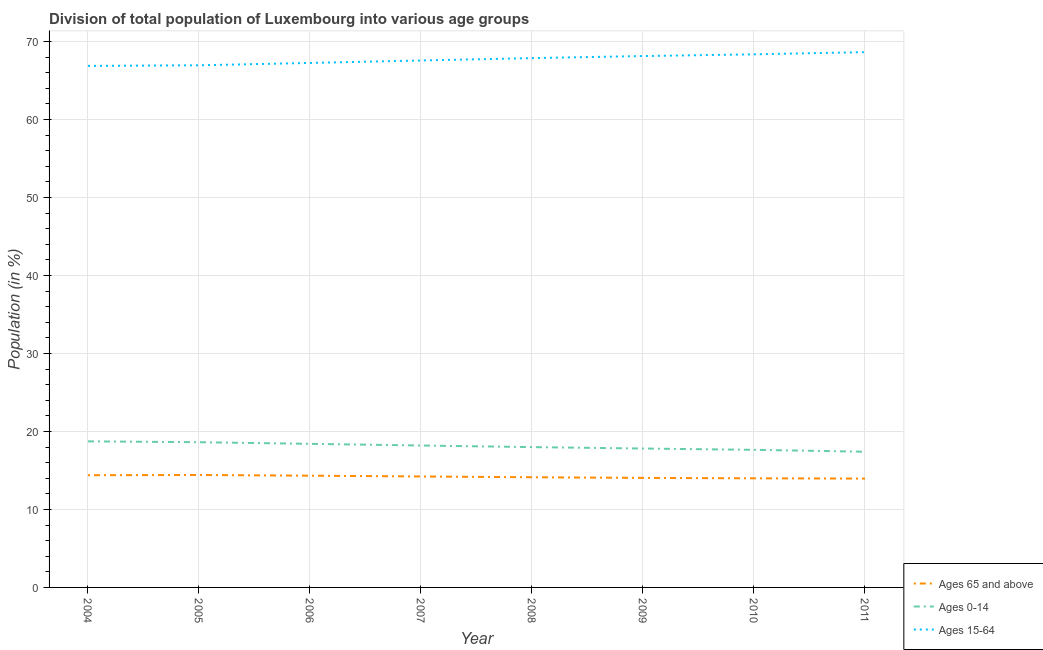Does the line corresponding to percentage of population within the age-group 15-64 intersect with the line corresponding to percentage of population within the age-group 0-14?
Your response must be concise. No. What is the percentage of population within the age-group of 65 and above in 2004?
Provide a short and direct response. 14.39. Across all years, what is the maximum percentage of population within the age-group 0-14?
Give a very brief answer. 18.73. Across all years, what is the minimum percentage of population within the age-group 0-14?
Ensure brevity in your answer.  17.4. In which year was the percentage of population within the age-group of 65 and above maximum?
Your answer should be compact. 2005. What is the total percentage of population within the age-group of 65 and above in the graph?
Keep it short and to the point. 113.49. What is the difference between the percentage of population within the age-group of 65 and above in 2007 and that in 2011?
Provide a short and direct response. 0.27. What is the difference between the percentage of population within the age-group of 65 and above in 2008 and the percentage of population within the age-group 0-14 in 2005?
Provide a succinct answer. -4.49. What is the average percentage of population within the age-group of 65 and above per year?
Provide a succinct answer. 14.19. In the year 2008, what is the difference between the percentage of population within the age-group of 65 and above and percentage of population within the age-group 0-14?
Make the answer very short. -3.87. What is the ratio of the percentage of population within the age-group of 65 and above in 2006 to that in 2009?
Keep it short and to the point. 1.02. Is the percentage of population within the age-group 0-14 in 2004 less than that in 2007?
Give a very brief answer. No. Is the difference between the percentage of population within the age-group of 65 and above in 2004 and 2009 greater than the difference between the percentage of population within the age-group 15-64 in 2004 and 2009?
Provide a succinct answer. Yes. What is the difference between the highest and the second highest percentage of population within the age-group 15-64?
Offer a very short reply. 0.28. What is the difference between the highest and the lowest percentage of population within the age-group of 65 and above?
Provide a short and direct response. 0.47. Is the sum of the percentage of population within the age-group of 65 and above in 2005 and 2009 greater than the maximum percentage of population within the age-group 15-64 across all years?
Ensure brevity in your answer.  No. Is it the case that in every year, the sum of the percentage of population within the age-group of 65 and above and percentage of population within the age-group 0-14 is greater than the percentage of population within the age-group 15-64?
Your answer should be very brief. No. Does the percentage of population within the age-group 0-14 monotonically increase over the years?
Provide a short and direct response. No. Is the percentage of population within the age-group 15-64 strictly greater than the percentage of population within the age-group of 65 and above over the years?
Keep it short and to the point. Yes. Is the percentage of population within the age-group 15-64 strictly less than the percentage of population within the age-group 0-14 over the years?
Make the answer very short. No. How many years are there in the graph?
Keep it short and to the point. 8. What is the difference between two consecutive major ticks on the Y-axis?
Provide a succinct answer. 10. Does the graph contain any zero values?
Your answer should be very brief. No. Does the graph contain grids?
Keep it short and to the point. Yes. What is the title of the graph?
Ensure brevity in your answer.  Division of total population of Luxembourg into various age groups
. What is the label or title of the X-axis?
Ensure brevity in your answer.  Year. What is the Population (in %) in Ages 65 and above in 2004?
Offer a very short reply. 14.39. What is the Population (in %) in Ages 0-14 in 2004?
Your answer should be compact. 18.73. What is the Population (in %) of Ages 15-64 in 2004?
Provide a short and direct response. 66.88. What is the Population (in %) in Ages 65 and above in 2005?
Your answer should be compact. 14.42. What is the Population (in %) of Ages 0-14 in 2005?
Give a very brief answer. 18.62. What is the Population (in %) in Ages 15-64 in 2005?
Provide a succinct answer. 66.96. What is the Population (in %) in Ages 65 and above in 2006?
Your response must be concise. 14.33. What is the Population (in %) in Ages 0-14 in 2006?
Provide a succinct answer. 18.41. What is the Population (in %) in Ages 15-64 in 2006?
Ensure brevity in your answer.  67.26. What is the Population (in %) in Ages 65 and above in 2007?
Your answer should be very brief. 14.23. What is the Population (in %) of Ages 0-14 in 2007?
Give a very brief answer. 18.2. What is the Population (in %) in Ages 15-64 in 2007?
Provide a succinct answer. 67.57. What is the Population (in %) of Ages 65 and above in 2008?
Make the answer very short. 14.13. What is the Population (in %) of Ages 0-14 in 2008?
Ensure brevity in your answer.  17.99. What is the Population (in %) of Ages 15-64 in 2008?
Offer a very short reply. 67.88. What is the Population (in %) of Ages 65 and above in 2009?
Make the answer very short. 14.05. What is the Population (in %) of Ages 0-14 in 2009?
Offer a very short reply. 17.81. What is the Population (in %) of Ages 15-64 in 2009?
Your answer should be compact. 68.14. What is the Population (in %) of Ages 65 and above in 2010?
Your response must be concise. 13.99. What is the Population (in %) in Ages 0-14 in 2010?
Your answer should be very brief. 17.64. What is the Population (in %) in Ages 15-64 in 2010?
Provide a succinct answer. 68.36. What is the Population (in %) of Ages 65 and above in 2011?
Give a very brief answer. 13.95. What is the Population (in %) in Ages 0-14 in 2011?
Ensure brevity in your answer.  17.4. What is the Population (in %) of Ages 15-64 in 2011?
Provide a succinct answer. 68.64. Across all years, what is the maximum Population (in %) of Ages 65 and above?
Your response must be concise. 14.42. Across all years, what is the maximum Population (in %) of Ages 0-14?
Give a very brief answer. 18.73. Across all years, what is the maximum Population (in %) of Ages 15-64?
Provide a short and direct response. 68.64. Across all years, what is the minimum Population (in %) of Ages 65 and above?
Make the answer very short. 13.95. Across all years, what is the minimum Population (in %) of Ages 0-14?
Provide a succinct answer. 17.4. Across all years, what is the minimum Population (in %) in Ages 15-64?
Keep it short and to the point. 66.88. What is the total Population (in %) of Ages 65 and above in the graph?
Give a very brief answer. 113.49. What is the total Population (in %) of Ages 0-14 in the graph?
Provide a short and direct response. 144.82. What is the total Population (in %) of Ages 15-64 in the graph?
Ensure brevity in your answer.  541.69. What is the difference between the Population (in %) in Ages 65 and above in 2004 and that in 2005?
Provide a short and direct response. -0.03. What is the difference between the Population (in %) in Ages 0-14 in 2004 and that in 2005?
Give a very brief answer. 0.11. What is the difference between the Population (in %) in Ages 15-64 in 2004 and that in 2005?
Offer a very short reply. -0.08. What is the difference between the Population (in %) of Ages 65 and above in 2004 and that in 2006?
Your answer should be compact. 0.06. What is the difference between the Population (in %) in Ages 0-14 in 2004 and that in 2006?
Your answer should be very brief. 0.32. What is the difference between the Population (in %) of Ages 15-64 in 2004 and that in 2006?
Offer a terse response. -0.38. What is the difference between the Population (in %) in Ages 65 and above in 2004 and that in 2007?
Your response must be concise. 0.16. What is the difference between the Population (in %) of Ages 0-14 in 2004 and that in 2007?
Provide a short and direct response. 0.54. What is the difference between the Population (in %) in Ages 15-64 in 2004 and that in 2007?
Give a very brief answer. -0.7. What is the difference between the Population (in %) in Ages 65 and above in 2004 and that in 2008?
Offer a very short reply. 0.26. What is the difference between the Population (in %) of Ages 0-14 in 2004 and that in 2008?
Provide a succinct answer. 0.74. What is the difference between the Population (in %) in Ages 15-64 in 2004 and that in 2008?
Your answer should be very brief. -1. What is the difference between the Population (in %) of Ages 65 and above in 2004 and that in 2009?
Your answer should be very brief. 0.34. What is the difference between the Population (in %) in Ages 0-14 in 2004 and that in 2009?
Keep it short and to the point. 0.92. What is the difference between the Population (in %) in Ages 15-64 in 2004 and that in 2009?
Your answer should be very brief. -1.26. What is the difference between the Population (in %) of Ages 65 and above in 2004 and that in 2010?
Your answer should be compact. 0.39. What is the difference between the Population (in %) in Ages 0-14 in 2004 and that in 2010?
Provide a succinct answer. 1.09. What is the difference between the Population (in %) of Ages 15-64 in 2004 and that in 2010?
Offer a very short reply. -1.48. What is the difference between the Population (in %) of Ages 65 and above in 2004 and that in 2011?
Your answer should be compact. 0.43. What is the difference between the Population (in %) of Ages 0-14 in 2004 and that in 2011?
Provide a succinct answer. 1.33. What is the difference between the Population (in %) in Ages 15-64 in 2004 and that in 2011?
Your response must be concise. -1.76. What is the difference between the Population (in %) in Ages 65 and above in 2005 and that in 2006?
Make the answer very short. 0.09. What is the difference between the Population (in %) in Ages 0-14 in 2005 and that in 2006?
Your response must be concise. 0.21. What is the difference between the Population (in %) of Ages 15-64 in 2005 and that in 2006?
Your answer should be very brief. -0.3. What is the difference between the Population (in %) in Ages 65 and above in 2005 and that in 2007?
Your answer should be very brief. 0.19. What is the difference between the Population (in %) of Ages 0-14 in 2005 and that in 2007?
Your answer should be very brief. 0.42. What is the difference between the Population (in %) in Ages 15-64 in 2005 and that in 2007?
Your answer should be compact. -0.62. What is the difference between the Population (in %) in Ages 65 and above in 2005 and that in 2008?
Provide a succinct answer. 0.29. What is the difference between the Population (in %) in Ages 0-14 in 2005 and that in 2008?
Your answer should be very brief. 0.63. What is the difference between the Population (in %) of Ages 15-64 in 2005 and that in 2008?
Your response must be concise. -0.92. What is the difference between the Population (in %) in Ages 65 and above in 2005 and that in 2009?
Keep it short and to the point. 0.38. What is the difference between the Population (in %) of Ages 0-14 in 2005 and that in 2009?
Provide a succinct answer. 0.81. What is the difference between the Population (in %) in Ages 15-64 in 2005 and that in 2009?
Provide a short and direct response. -1.19. What is the difference between the Population (in %) in Ages 65 and above in 2005 and that in 2010?
Provide a succinct answer. 0.43. What is the difference between the Population (in %) in Ages 0-14 in 2005 and that in 2010?
Give a very brief answer. 0.98. What is the difference between the Population (in %) of Ages 15-64 in 2005 and that in 2010?
Make the answer very short. -1.41. What is the difference between the Population (in %) of Ages 65 and above in 2005 and that in 2011?
Your answer should be compact. 0.47. What is the difference between the Population (in %) of Ages 0-14 in 2005 and that in 2011?
Keep it short and to the point. 1.22. What is the difference between the Population (in %) in Ages 15-64 in 2005 and that in 2011?
Give a very brief answer. -1.69. What is the difference between the Population (in %) of Ages 65 and above in 2006 and that in 2007?
Your answer should be very brief. 0.1. What is the difference between the Population (in %) in Ages 0-14 in 2006 and that in 2007?
Give a very brief answer. 0.21. What is the difference between the Population (in %) in Ages 15-64 in 2006 and that in 2007?
Your response must be concise. -0.31. What is the difference between the Population (in %) in Ages 65 and above in 2006 and that in 2008?
Offer a terse response. 0.2. What is the difference between the Population (in %) in Ages 0-14 in 2006 and that in 2008?
Your response must be concise. 0.42. What is the difference between the Population (in %) of Ages 15-64 in 2006 and that in 2008?
Offer a terse response. -0.62. What is the difference between the Population (in %) of Ages 65 and above in 2006 and that in 2009?
Provide a short and direct response. 0.28. What is the difference between the Population (in %) of Ages 0-14 in 2006 and that in 2009?
Your response must be concise. 0.6. What is the difference between the Population (in %) of Ages 15-64 in 2006 and that in 2009?
Provide a short and direct response. -0.88. What is the difference between the Population (in %) in Ages 65 and above in 2006 and that in 2010?
Keep it short and to the point. 0.34. What is the difference between the Population (in %) of Ages 0-14 in 2006 and that in 2010?
Ensure brevity in your answer.  0.77. What is the difference between the Population (in %) in Ages 15-64 in 2006 and that in 2010?
Provide a succinct answer. -1.1. What is the difference between the Population (in %) in Ages 65 and above in 2006 and that in 2011?
Provide a short and direct response. 0.37. What is the difference between the Population (in %) of Ages 0-14 in 2006 and that in 2011?
Offer a terse response. 1.01. What is the difference between the Population (in %) in Ages 15-64 in 2006 and that in 2011?
Make the answer very short. -1.38. What is the difference between the Population (in %) of Ages 65 and above in 2007 and that in 2008?
Offer a terse response. 0.1. What is the difference between the Population (in %) in Ages 0-14 in 2007 and that in 2008?
Keep it short and to the point. 0.2. What is the difference between the Population (in %) in Ages 15-64 in 2007 and that in 2008?
Provide a succinct answer. -0.3. What is the difference between the Population (in %) in Ages 65 and above in 2007 and that in 2009?
Provide a succinct answer. 0.18. What is the difference between the Population (in %) in Ages 0-14 in 2007 and that in 2009?
Offer a very short reply. 0.39. What is the difference between the Population (in %) of Ages 15-64 in 2007 and that in 2009?
Make the answer very short. -0.57. What is the difference between the Population (in %) of Ages 65 and above in 2007 and that in 2010?
Your answer should be very brief. 0.23. What is the difference between the Population (in %) of Ages 0-14 in 2007 and that in 2010?
Offer a very short reply. 0.55. What is the difference between the Population (in %) of Ages 15-64 in 2007 and that in 2010?
Offer a very short reply. -0.79. What is the difference between the Population (in %) in Ages 65 and above in 2007 and that in 2011?
Give a very brief answer. 0.27. What is the difference between the Population (in %) in Ages 0-14 in 2007 and that in 2011?
Provide a short and direct response. 0.8. What is the difference between the Population (in %) in Ages 15-64 in 2007 and that in 2011?
Offer a very short reply. -1.07. What is the difference between the Population (in %) of Ages 65 and above in 2008 and that in 2009?
Your answer should be compact. 0.08. What is the difference between the Population (in %) in Ages 0-14 in 2008 and that in 2009?
Keep it short and to the point. 0.18. What is the difference between the Population (in %) in Ages 15-64 in 2008 and that in 2009?
Make the answer very short. -0.27. What is the difference between the Population (in %) of Ages 65 and above in 2008 and that in 2010?
Your response must be concise. 0.14. What is the difference between the Population (in %) in Ages 0-14 in 2008 and that in 2010?
Your answer should be compact. 0.35. What is the difference between the Population (in %) in Ages 15-64 in 2008 and that in 2010?
Your response must be concise. -0.49. What is the difference between the Population (in %) of Ages 65 and above in 2008 and that in 2011?
Provide a succinct answer. 0.17. What is the difference between the Population (in %) of Ages 0-14 in 2008 and that in 2011?
Keep it short and to the point. 0.59. What is the difference between the Population (in %) of Ages 15-64 in 2008 and that in 2011?
Keep it short and to the point. -0.76. What is the difference between the Population (in %) of Ages 65 and above in 2009 and that in 2010?
Offer a very short reply. 0.05. What is the difference between the Population (in %) of Ages 0-14 in 2009 and that in 2010?
Offer a terse response. 0.17. What is the difference between the Population (in %) in Ages 15-64 in 2009 and that in 2010?
Offer a terse response. -0.22. What is the difference between the Population (in %) in Ages 65 and above in 2009 and that in 2011?
Your answer should be very brief. 0.09. What is the difference between the Population (in %) in Ages 0-14 in 2009 and that in 2011?
Give a very brief answer. 0.41. What is the difference between the Population (in %) in Ages 15-64 in 2009 and that in 2011?
Your answer should be very brief. -0.5. What is the difference between the Population (in %) of Ages 65 and above in 2010 and that in 2011?
Your answer should be very brief. 0.04. What is the difference between the Population (in %) of Ages 0-14 in 2010 and that in 2011?
Your answer should be compact. 0.24. What is the difference between the Population (in %) in Ages 15-64 in 2010 and that in 2011?
Your response must be concise. -0.28. What is the difference between the Population (in %) in Ages 65 and above in 2004 and the Population (in %) in Ages 0-14 in 2005?
Make the answer very short. -4.23. What is the difference between the Population (in %) in Ages 65 and above in 2004 and the Population (in %) in Ages 15-64 in 2005?
Keep it short and to the point. -52.57. What is the difference between the Population (in %) of Ages 0-14 in 2004 and the Population (in %) of Ages 15-64 in 2005?
Provide a short and direct response. -48.22. What is the difference between the Population (in %) in Ages 65 and above in 2004 and the Population (in %) in Ages 0-14 in 2006?
Ensure brevity in your answer.  -4.02. What is the difference between the Population (in %) in Ages 65 and above in 2004 and the Population (in %) in Ages 15-64 in 2006?
Offer a terse response. -52.87. What is the difference between the Population (in %) of Ages 0-14 in 2004 and the Population (in %) of Ages 15-64 in 2006?
Keep it short and to the point. -48.52. What is the difference between the Population (in %) in Ages 65 and above in 2004 and the Population (in %) in Ages 0-14 in 2007?
Your answer should be very brief. -3.81. What is the difference between the Population (in %) in Ages 65 and above in 2004 and the Population (in %) in Ages 15-64 in 2007?
Keep it short and to the point. -53.19. What is the difference between the Population (in %) in Ages 0-14 in 2004 and the Population (in %) in Ages 15-64 in 2007?
Offer a terse response. -48.84. What is the difference between the Population (in %) of Ages 65 and above in 2004 and the Population (in %) of Ages 0-14 in 2008?
Your answer should be compact. -3.61. What is the difference between the Population (in %) of Ages 65 and above in 2004 and the Population (in %) of Ages 15-64 in 2008?
Your answer should be very brief. -53.49. What is the difference between the Population (in %) of Ages 0-14 in 2004 and the Population (in %) of Ages 15-64 in 2008?
Your answer should be very brief. -49.14. What is the difference between the Population (in %) of Ages 65 and above in 2004 and the Population (in %) of Ages 0-14 in 2009?
Provide a short and direct response. -3.42. What is the difference between the Population (in %) in Ages 65 and above in 2004 and the Population (in %) in Ages 15-64 in 2009?
Your answer should be very brief. -53.76. What is the difference between the Population (in %) in Ages 0-14 in 2004 and the Population (in %) in Ages 15-64 in 2009?
Your answer should be very brief. -49.41. What is the difference between the Population (in %) in Ages 65 and above in 2004 and the Population (in %) in Ages 0-14 in 2010?
Make the answer very short. -3.26. What is the difference between the Population (in %) in Ages 65 and above in 2004 and the Population (in %) in Ages 15-64 in 2010?
Your response must be concise. -53.98. What is the difference between the Population (in %) in Ages 0-14 in 2004 and the Population (in %) in Ages 15-64 in 2010?
Make the answer very short. -49.63. What is the difference between the Population (in %) of Ages 65 and above in 2004 and the Population (in %) of Ages 0-14 in 2011?
Provide a succinct answer. -3.02. What is the difference between the Population (in %) of Ages 65 and above in 2004 and the Population (in %) of Ages 15-64 in 2011?
Provide a short and direct response. -54.25. What is the difference between the Population (in %) in Ages 0-14 in 2004 and the Population (in %) in Ages 15-64 in 2011?
Make the answer very short. -49.91. What is the difference between the Population (in %) of Ages 65 and above in 2005 and the Population (in %) of Ages 0-14 in 2006?
Your answer should be compact. -3.99. What is the difference between the Population (in %) in Ages 65 and above in 2005 and the Population (in %) in Ages 15-64 in 2006?
Give a very brief answer. -52.84. What is the difference between the Population (in %) in Ages 0-14 in 2005 and the Population (in %) in Ages 15-64 in 2006?
Keep it short and to the point. -48.64. What is the difference between the Population (in %) of Ages 65 and above in 2005 and the Population (in %) of Ages 0-14 in 2007?
Your answer should be compact. -3.78. What is the difference between the Population (in %) of Ages 65 and above in 2005 and the Population (in %) of Ages 15-64 in 2007?
Your response must be concise. -53.15. What is the difference between the Population (in %) in Ages 0-14 in 2005 and the Population (in %) in Ages 15-64 in 2007?
Give a very brief answer. -48.95. What is the difference between the Population (in %) of Ages 65 and above in 2005 and the Population (in %) of Ages 0-14 in 2008?
Your response must be concise. -3.57. What is the difference between the Population (in %) in Ages 65 and above in 2005 and the Population (in %) in Ages 15-64 in 2008?
Your answer should be very brief. -53.46. What is the difference between the Population (in %) in Ages 0-14 in 2005 and the Population (in %) in Ages 15-64 in 2008?
Your answer should be very brief. -49.25. What is the difference between the Population (in %) in Ages 65 and above in 2005 and the Population (in %) in Ages 0-14 in 2009?
Offer a very short reply. -3.39. What is the difference between the Population (in %) in Ages 65 and above in 2005 and the Population (in %) in Ages 15-64 in 2009?
Your response must be concise. -53.72. What is the difference between the Population (in %) of Ages 0-14 in 2005 and the Population (in %) of Ages 15-64 in 2009?
Provide a succinct answer. -49.52. What is the difference between the Population (in %) in Ages 65 and above in 2005 and the Population (in %) in Ages 0-14 in 2010?
Make the answer very short. -3.22. What is the difference between the Population (in %) in Ages 65 and above in 2005 and the Population (in %) in Ages 15-64 in 2010?
Your answer should be very brief. -53.94. What is the difference between the Population (in %) in Ages 0-14 in 2005 and the Population (in %) in Ages 15-64 in 2010?
Your answer should be very brief. -49.74. What is the difference between the Population (in %) in Ages 65 and above in 2005 and the Population (in %) in Ages 0-14 in 2011?
Your answer should be compact. -2.98. What is the difference between the Population (in %) in Ages 65 and above in 2005 and the Population (in %) in Ages 15-64 in 2011?
Keep it short and to the point. -54.22. What is the difference between the Population (in %) of Ages 0-14 in 2005 and the Population (in %) of Ages 15-64 in 2011?
Provide a short and direct response. -50.02. What is the difference between the Population (in %) in Ages 65 and above in 2006 and the Population (in %) in Ages 0-14 in 2007?
Offer a very short reply. -3.87. What is the difference between the Population (in %) of Ages 65 and above in 2006 and the Population (in %) of Ages 15-64 in 2007?
Give a very brief answer. -53.24. What is the difference between the Population (in %) of Ages 0-14 in 2006 and the Population (in %) of Ages 15-64 in 2007?
Your answer should be compact. -49.16. What is the difference between the Population (in %) of Ages 65 and above in 2006 and the Population (in %) of Ages 0-14 in 2008?
Keep it short and to the point. -3.67. What is the difference between the Population (in %) in Ages 65 and above in 2006 and the Population (in %) in Ages 15-64 in 2008?
Your answer should be very brief. -53.55. What is the difference between the Population (in %) in Ages 0-14 in 2006 and the Population (in %) in Ages 15-64 in 2008?
Make the answer very short. -49.46. What is the difference between the Population (in %) of Ages 65 and above in 2006 and the Population (in %) of Ages 0-14 in 2009?
Ensure brevity in your answer.  -3.48. What is the difference between the Population (in %) of Ages 65 and above in 2006 and the Population (in %) of Ages 15-64 in 2009?
Keep it short and to the point. -53.81. What is the difference between the Population (in %) in Ages 0-14 in 2006 and the Population (in %) in Ages 15-64 in 2009?
Provide a succinct answer. -49.73. What is the difference between the Population (in %) in Ages 65 and above in 2006 and the Population (in %) in Ages 0-14 in 2010?
Make the answer very short. -3.32. What is the difference between the Population (in %) in Ages 65 and above in 2006 and the Population (in %) in Ages 15-64 in 2010?
Make the answer very short. -54.03. What is the difference between the Population (in %) of Ages 0-14 in 2006 and the Population (in %) of Ages 15-64 in 2010?
Provide a short and direct response. -49.95. What is the difference between the Population (in %) of Ages 65 and above in 2006 and the Population (in %) of Ages 0-14 in 2011?
Give a very brief answer. -3.07. What is the difference between the Population (in %) in Ages 65 and above in 2006 and the Population (in %) in Ages 15-64 in 2011?
Offer a terse response. -54.31. What is the difference between the Population (in %) in Ages 0-14 in 2006 and the Population (in %) in Ages 15-64 in 2011?
Give a very brief answer. -50.23. What is the difference between the Population (in %) of Ages 65 and above in 2007 and the Population (in %) of Ages 0-14 in 2008?
Keep it short and to the point. -3.77. What is the difference between the Population (in %) in Ages 65 and above in 2007 and the Population (in %) in Ages 15-64 in 2008?
Keep it short and to the point. -53.65. What is the difference between the Population (in %) of Ages 0-14 in 2007 and the Population (in %) of Ages 15-64 in 2008?
Your answer should be very brief. -49.68. What is the difference between the Population (in %) in Ages 65 and above in 2007 and the Population (in %) in Ages 0-14 in 2009?
Offer a very short reply. -3.58. What is the difference between the Population (in %) in Ages 65 and above in 2007 and the Population (in %) in Ages 15-64 in 2009?
Provide a short and direct response. -53.92. What is the difference between the Population (in %) of Ages 0-14 in 2007 and the Population (in %) of Ages 15-64 in 2009?
Ensure brevity in your answer.  -49.94. What is the difference between the Population (in %) in Ages 65 and above in 2007 and the Population (in %) in Ages 0-14 in 2010?
Ensure brevity in your answer.  -3.42. What is the difference between the Population (in %) in Ages 65 and above in 2007 and the Population (in %) in Ages 15-64 in 2010?
Keep it short and to the point. -54.13. What is the difference between the Population (in %) in Ages 0-14 in 2007 and the Population (in %) in Ages 15-64 in 2010?
Offer a terse response. -50.16. What is the difference between the Population (in %) in Ages 65 and above in 2007 and the Population (in %) in Ages 0-14 in 2011?
Provide a short and direct response. -3.17. What is the difference between the Population (in %) in Ages 65 and above in 2007 and the Population (in %) in Ages 15-64 in 2011?
Ensure brevity in your answer.  -54.41. What is the difference between the Population (in %) in Ages 0-14 in 2007 and the Population (in %) in Ages 15-64 in 2011?
Keep it short and to the point. -50.44. What is the difference between the Population (in %) of Ages 65 and above in 2008 and the Population (in %) of Ages 0-14 in 2009?
Your answer should be compact. -3.68. What is the difference between the Population (in %) in Ages 65 and above in 2008 and the Population (in %) in Ages 15-64 in 2009?
Your response must be concise. -54.01. What is the difference between the Population (in %) of Ages 0-14 in 2008 and the Population (in %) of Ages 15-64 in 2009?
Ensure brevity in your answer.  -50.15. What is the difference between the Population (in %) of Ages 65 and above in 2008 and the Population (in %) of Ages 0-14 in 2010?
Provide a short and direct response. -3.52. What is the difference between the Population (in %) in Ages 65 and above in 2008 and the Population (in %) in Ages 15-64 in 2010?
Keep it short and to the point. -54.23. What is the difference between the Population (in %) of Ages 0-14 in 2008 and the Population (in %) of Ages 15-64 in 2010?
Your response must be concise. -50.37. What is the difference between the Population (in %) of Ages 65 and above in 2008 and the Population (in %) of Ages 0-14 in 2011?
Ensure brevity in your answer.  -3.27. What is the difference between the Population (in %) in Ages 65 and above in 2008 and the Population (in %) in Ages 15-64 in 2011?
Your answer should be very brief. -54.51. What is the difference between the Population (in %) of Ages 0-14 in 2008 and the Population (in %) of Ages 15-64 in 2011?
Provide a short and direct response. -50.65. What is the difference between the Population (in %) in Ages 65 and above in 2009 and the Population (in %) in Ages 0-14 in 2010?
Offer a terse response. -3.6. What is the difference between the Population (in %) of Ages 65 and above in 2009 and the Population (in %) of Ages 15-64 in 2010?
Your answer should be compact. -54.32. What is the difference between the Population (in %) of Ages 0-14 in 2009 and the Population (in %) of Ages 15-64 in 2010?
Ensure brevity in your answer.  -50.55. What is the difference between the Population (in %) of Ages 65 and above in 2009 and the Population (in %) of Ages 0-14 in 2011?
Your answer should be very brief. -3.36. What is the difference between the Population (in %) of Ages 65 and above in 2009 and the Population (in %) of Ages 15-64 in 2011?
Keep it short and to the point. -54.6. What is the difference between the Population (in %) of Ages 0-14 in 2009 and the Population (in %) of Ages 15-64 in 2011?
Make the answer very short. -50.83. What is the difference between the Population (in %) of Ages 65 and above in 2010 and the Population (in %) of Ages 0-14 in 2011?
Offer a very short reply. -3.41. What is the difference between the Population (in %) of Ages 65 and above in 2010 and the Population (in %) of Ages 15-64 in 2011?
Offer a terse response. -54.65. What is the difference between the Population (in %) of Ages 0-14 in 2010 and the Population (in %) of Ages 15-64 in 2011?
Keep it short and to the point. -51. What is the average Population (in %) in Ages 65 and above per year?
Provide a short and direct response. 14.19. What is the average Population (in %) of Ages 0-14 per year?
Provide a succinct answer. 18.1. What is the average Population (in %) of Ages 15-64 per year?
Your answer should be compact. 67.71. In the year 2004, what is the difference between the Population (in %) in Ages 65 and above and Population (in %) in Ages 0-14?
Offer a very short reply. -4.35. In the year 2004, what is the difference between the Population (in %) of Ages 65 and above and Population (in %) of Ages 15-64?
Offer a terse response. -52.49. In the year 2004, what is the difference between the Population (in %) of Ages 0-14 and Population (in %) of Ages 15-64?
Keep it short and to the point. -48.14. In the year 2005, what is the difference between the Population (in %) in Ages 65 and above and Population (in %) in Ages 0-14?
Give a very brief answer. -4.2. In the year 2005, what is the difference between the Population (in %) in Ages 65 and above and Population (in %) in Ages 15-64?
Your answer should be compact. -52.53. In the year 2005, what is the difference between the Population (in %) in Ages 0-14 and Population (in %) in Ages 15-64?
Make the answer very short. -48.33. In the year 2006, what is the difference between the Population (in %) in Ages 65 and above and Population (in %) in Ages 0-14?
Your answer should be very brief. -4.08. In the year 2006, what is the difference between the Population (in %) in Ages 65 and above and Population (in %) in Ages 15-64?
Provide a succinct answer. -52.93. In the year 2006, what is the difference between the Population (in %) of Ages 0-14 and Population (in %) of Ages 15-64?
Give a very brief answer. -48.85. In the year 2007, what is the difference between the Population (in %) in Ages 65 and above and Population (in %) in Ages 0-14?
Give a very brief answer. -3.97. In the year 2007, what is the difference between the Population (in %) of Ages 65 and above and Population (in %) of Ages 15-64?
Keep it short and to the point. -53.35. In the year 2007, what is the difference between the Population (in %) of Ages 0-14 and Population (in %) of Ages 15-64?
Give a very brief answer. -49.38. In the year 2008, what is the difference between the Population (in %) of Ages 65 and above and Population (in %) of Ages 0-14?
Offer a terse response. -3.87. In the year 2008, what is the difference between the Population (in %) of Ages 65 and above and Population (in %) of Ages 15-64?
Keep it short and to the point. -53.75. In the year 2008, what is the difference between the Population (in %) of Ages 0-14 and Population (in %) of Ages 15-64?
Your answer should be very brief. -49.88. In the year 2009, what is the difference between the Population (in %) in Ages 65 and above and Population (in %) in Ages 0-14?
Your answer should be very brief. -3.77. In the year 2009, what is the difference between the Population (in %) in Ages 65 and above and Population (in %) in Ages 15-64?
Offer a very short reply. -54.1. In the year 2009, what is the difference between the Population (in %) in Ages 0-14 and Population (in %) in Ages 15-64?
Offer a terse response. -50.33. In the year 2010, what is the difference between the Population (in %) of Ages 65 and above and Population (in %) of Ages 0-14?
Your answer should be very brief. -3.65. In the year 2010, what is the difference between the Population (in %) of Ages 65 and above and Population (in %) of Ages 15-64?
Make the answer very short. -54.37. In the year 2010, what is the difference between the Population (in %) in Ages 0-14 and Population (in %) in Ages 15-64?
Make the answer very short. -50.72. In the year 2011, what is the difference between the Population (in %) in Ages 65 and above and Population (in %) in Ages 0-14?
Provide a succinct answer. -3.45. In the year 2011, what is the difference between the Population (in %) of Ages 65 and above and Population (in %) of Ages 15-64?
Your answer should be compact. -54.69. In the year 2011, what is the difference between the Population (in %) in Ages 0-14 and Population (in %) in Ages 15-64?
Your answer should be compact. -51.24. What is the ratio of the Population (in %) of Ages 15-64 in 2004 to that in 2005?
Offer a very short reply. 1. What is the ratio of the Population (in %) in Ages 0-14 in 2004 to that in 2006?
Provide a short and direct response. 1.02. What is the ratio of the Population (in %) in Ages 15-64 in 2004 to that in 2006?
Make the answer very short. 0.99. What is the ratio of the Population (in %) in Ages 65 and above in 2004 to that in 2007?
Give a very brief answer. 1.01. What is the ratio of the Population (in %) in Ages 0-14 in 2004 to that in 2007?
Offer a very short reply. 1.03. What is the ratio of the Population (in %) in Ages 15-64 in 2004 to that in 2007?
Provide a short and direct response. 0.99. What is the ratio of the Population (in %) of Ages 65 and above in 2004 to that in 2008?
Your answer should be very brief. 1.02. What is the ratio of the Population (in %) in Ages 0-14 in 2004 to that in 2008?
Make the answer very short. 1.04. What is the ratio of the Population (in %) of Ages 65 and above in 2004 to that in 2009?
Offer a terse response. 1.02. What is the ratio of the Population (in %) of Ages 0-14 in 2004 to that in 2009?
Ensure brevity in your answer.  1.05. What is the ratio of the Population (in %) of Ages 15-64 in 2004 to that in 2009?
Provide a short and direct response. 0.98. What is the ratio of the Population (in %) in Ages 65 and above in 2004 to that in 2010?
Your response must be concise. 1.03. What is the ratio of the Population (in %) in Ages 0-14 in 2004 to that in 2010?
Offer a terse response. 1.06. What is the ratio of the Population (in %) in Ages 15-64 in 2004 to that in 2010?
Give a very brief answer. 0.98. What is the ratio of the Population (in %) of Ages 65 and above in 2004 to that in 2011?
Provide a succinct answer. 1.03. What is the ratio of the Population (in %) in Ages 0-14 in 2004 to that in 2011?
Your answer should be compact. 1.08. What is the ratio of the Population (in %) of Ages 15-64 in 2004 to that in 2011?
Offer a very short reply. 0.97. What is the ratio of the Population (in %) of Ages 65 and above in 2005 to that in 2006?
Offer a very short reply. 1.01. What is the ratio of the Population (in %) in Ages 0-14 in 2005 to that in 2006?
Provide a succinct answer. 1.01. What is the ratio of the Population (in %) in Ages 65 and above in 2005 to that in 2007?
Your response must be concise. 1.01. What is the ratio of the Population (in %) of Ages 0-14 in 2005 to that in 2007?
Your response must be concise. 1.02. What is the ratio of the Population (in %) of Ages 15-64 in 2005 to that in 2007?
Provide a succinct answer. 0.99. What is the ratio of the Population (in %) in Ages 65 and above in 2005 to that in 2008?
Offer a terse response. 1.02. What is the ratio of the Population (in %) of Ages 0-14 in 2005 to that in 2008?
Provide a short and direct response. 1.03. What is the ratio of the Population (in %) in Ages 15-64 in 2005 to that in 2008?
Provide a short and direct response. 0.99. What is the ratio of the Population (in %) in Ages 65 and above in 2005 to that in 2009?
Provide a short and direct response. 1.03. What is the ratio of the Population (in %) in Ages 0-14 in 2005 to that in 2009?
Give a very brief answer. 1.05. What is the ratio of the Population (in %) in Ages 15-64 in 2005 to that in 2009?
Offer a terse response. 0.98. What is the ratio of the Population (in %) in Ages 65 and above in 2005 to that in 2010?
Your answer should be very brief. 1.03. What is the ratio of the Population (in %) of Ages 0-14 in 2005 to that in 2010?
Offer a very short reply. 1.06. What is the ratio of the Population (in %) of Ages 15-64 in 2005 to that in 2010?
Offer a terse response. 0.98. What is the ratio of the Population (in %) in Ages 65 and above in 2005 to that in 2011?
Your answer should be compact. 1.03. What is the ratio of the Population (in %) of Ages 0-14 in 2005 to that in 2011?
Keep it short and to the point. 1.07. What is the ratio of the Population (in %) in Ages 15-64 in 2005 to that in 2011?
Your response must be concise. 0.98. What is the ratio of the Population (in %) of Ages 65 and above in 2006 to that in 2007?
Your response must be concise. 1.01. What is the ratio of the Population (in %) in Ages 0-14 in 2006 to that in 2007?
Offer a terse response. 1.01. What is the ratio of the Population (in %) in Ages 15-64 in 2006 to that in 2007?
Provide a succinct answer. 1. What is the ratio of the Population (in %) of Ages 65 and above in 2006 to that in 2008?
Keep it short and to the point. 1.01. What is the ratio of the Population (in %) in Ages 0-14 in 2006 to that in 2008?
Make the answer very short. 1.02. What is the ratio of the Population (in %) in Ages 15-64 in 2006 to that in 2008?
Keep it short and to the point. 0.99. What is the ratio of the Population (in %) in Ages 65 and above in 2006 to that in 2009?
Make the answer very short. 1.02. What is the ratio of the Population (in %) of Ages 0-14 in 2006 to that in 2009?
Ensure brevity in your answer.  1.03. What is the ratio of the Population (in %) in Ages 15-64 in 2006 to that in 2009?
Keep it short and to the point. 0.99. What is the ratio of the Population (in %) in Ages 0-14 in 2006 to that in 2010?
Keep it short and to the point. 1.04. What is the ratio of the Population (in %) in Ages 15-64 in 2006 to that in 2010?
Provide a succinct answer. 0.98. What is the ratio of the Population (in %) of Ages 65 and above in 2006 to that in 2011?
Your answer should be compact. 1.03. What is the ratio of the Population (in %) of Ages 0-14 in 2006 to that in 2011?
Ensure brevity in your answer.  1.06. What is the ratio of the Population (in %) of Ages 15-64 in 2006 to that in 2011?
Make the answer very short. 0.98. What is the ratio of the Population (in %) in Ages 0-14 in 2007 to that in 2008?
Provide a short and direct response. 1.01. What is the ratio of the Population (in %) in Ages 65 and above in 2007 to that in 2009?
Keep it short and to the point. 1.01. What is the ratio of the Population (in %) of Ages 0-14 in 2007 to that in 2009?
Keep it short and to the point. 1.02. What is the ratio of the Population (in %) of Ages 65 and above in 2007 to that in 2010?
Keep it short and to the point. 1.02. What is the ratio of the Population (in %) in Ages 0-14 in 2007 to that in 2010?
Your response must be concise. 1.03. What is the ratio of the Population (in %) of Ages 65 and above in 2007 to that in 2011?
Keep it short and to the point. 1.02. What is the ratio of the Population (in %) in Ages 0-14 in 2007 to that in 2011?
Your answer should be very brief. 1.05. What is the ratio of the Population (in %) of Ages 15-64 in 2007 to that in 2011?
Your answer should be very brief. 0.98. What is the ratio of the Population (in %) of Ages 65 and above in 2008 to that in 2009?
Ensure brevity in your answer.  1.01. What is the ratio of the Population (in %) of Ages 0-14 in 2008 to that in 2009?
Provide a short and direct response. 1.01. What is the ratio of the Population (in %) in Ages 65 and above in 2008 to that in 2010?
Provide a succinct answer. 1.01. What is the ratio of the Population (in %) in Ages 0-14 in 2008 to that in 2010?
Your answer should be very brief. 1.02. What is the ratio of the Population (in %) of Ages 15-64 in 2008 to that in 2010?
Offer a very short reply. 0.99. What is the ratio of the Population (in %) in Ages 65 and above in 2008 to that in 2011?
Offer a terse response. 1.01. What is the ratio of the Population (in %) in Ages 0-14 in 2008 to that in 2011?
Provide a succinct answer. 1.03. What is the ratio of the Population (in %) in Ages 15-64 in 2008 to that in 2011?
Offer a very short reply. 0.99. What is the ratio of the Population (in %) of Ages 0-14 in 2009 to that in 2010?
Your response must be concise. 1.01. What is the ratio of the Population (in %) in Ages 65 and above in 2009 to that in 2011?
Your answer should be compact. 1.01. What is the ratio of the Population (in %) in Ages 0-14 in 2009 to that in 2011?
Ensure brevity in your answer.  1.02. What is the ratio of the Population (in %) in Ages 15-64 in 2009 to that in 2011?
Your answer should be compact. 0.99. What is the ratio of the Population (in %) in Ages 0-14 in 2010 to that in 2011?
Make the answer very short. 1.01. What is the ratio of the Population (in %) of Ages 15-64 in 2010 to that in 2011?
Your answer should be compact. 1. What is the difference between the highest and the second highest Population (in %) of Ages 65 and above?
Your answer should be compact. 0.03. What is the difference between the highest and the second highest Population (in %) of Ages 0-14?
Ensure brevity in your answer.  0.11. What is the difference between the highest and the second highest Population (in %) in Ages 15-64?
Your answer should be compact. 0.28. What is the difference between the highest and the lowest Population (in %) of Ages 65 and above?
Provide a succinct answer. 0.47. What is the difference between the highest and the lowest Population (in %) of Ages 0-14?
Offer a very short reply. 1.33. What is the difference between the highest and the lowest Population (in %) of Ages 15-64?
Your answer should be very brief. 1.76. 